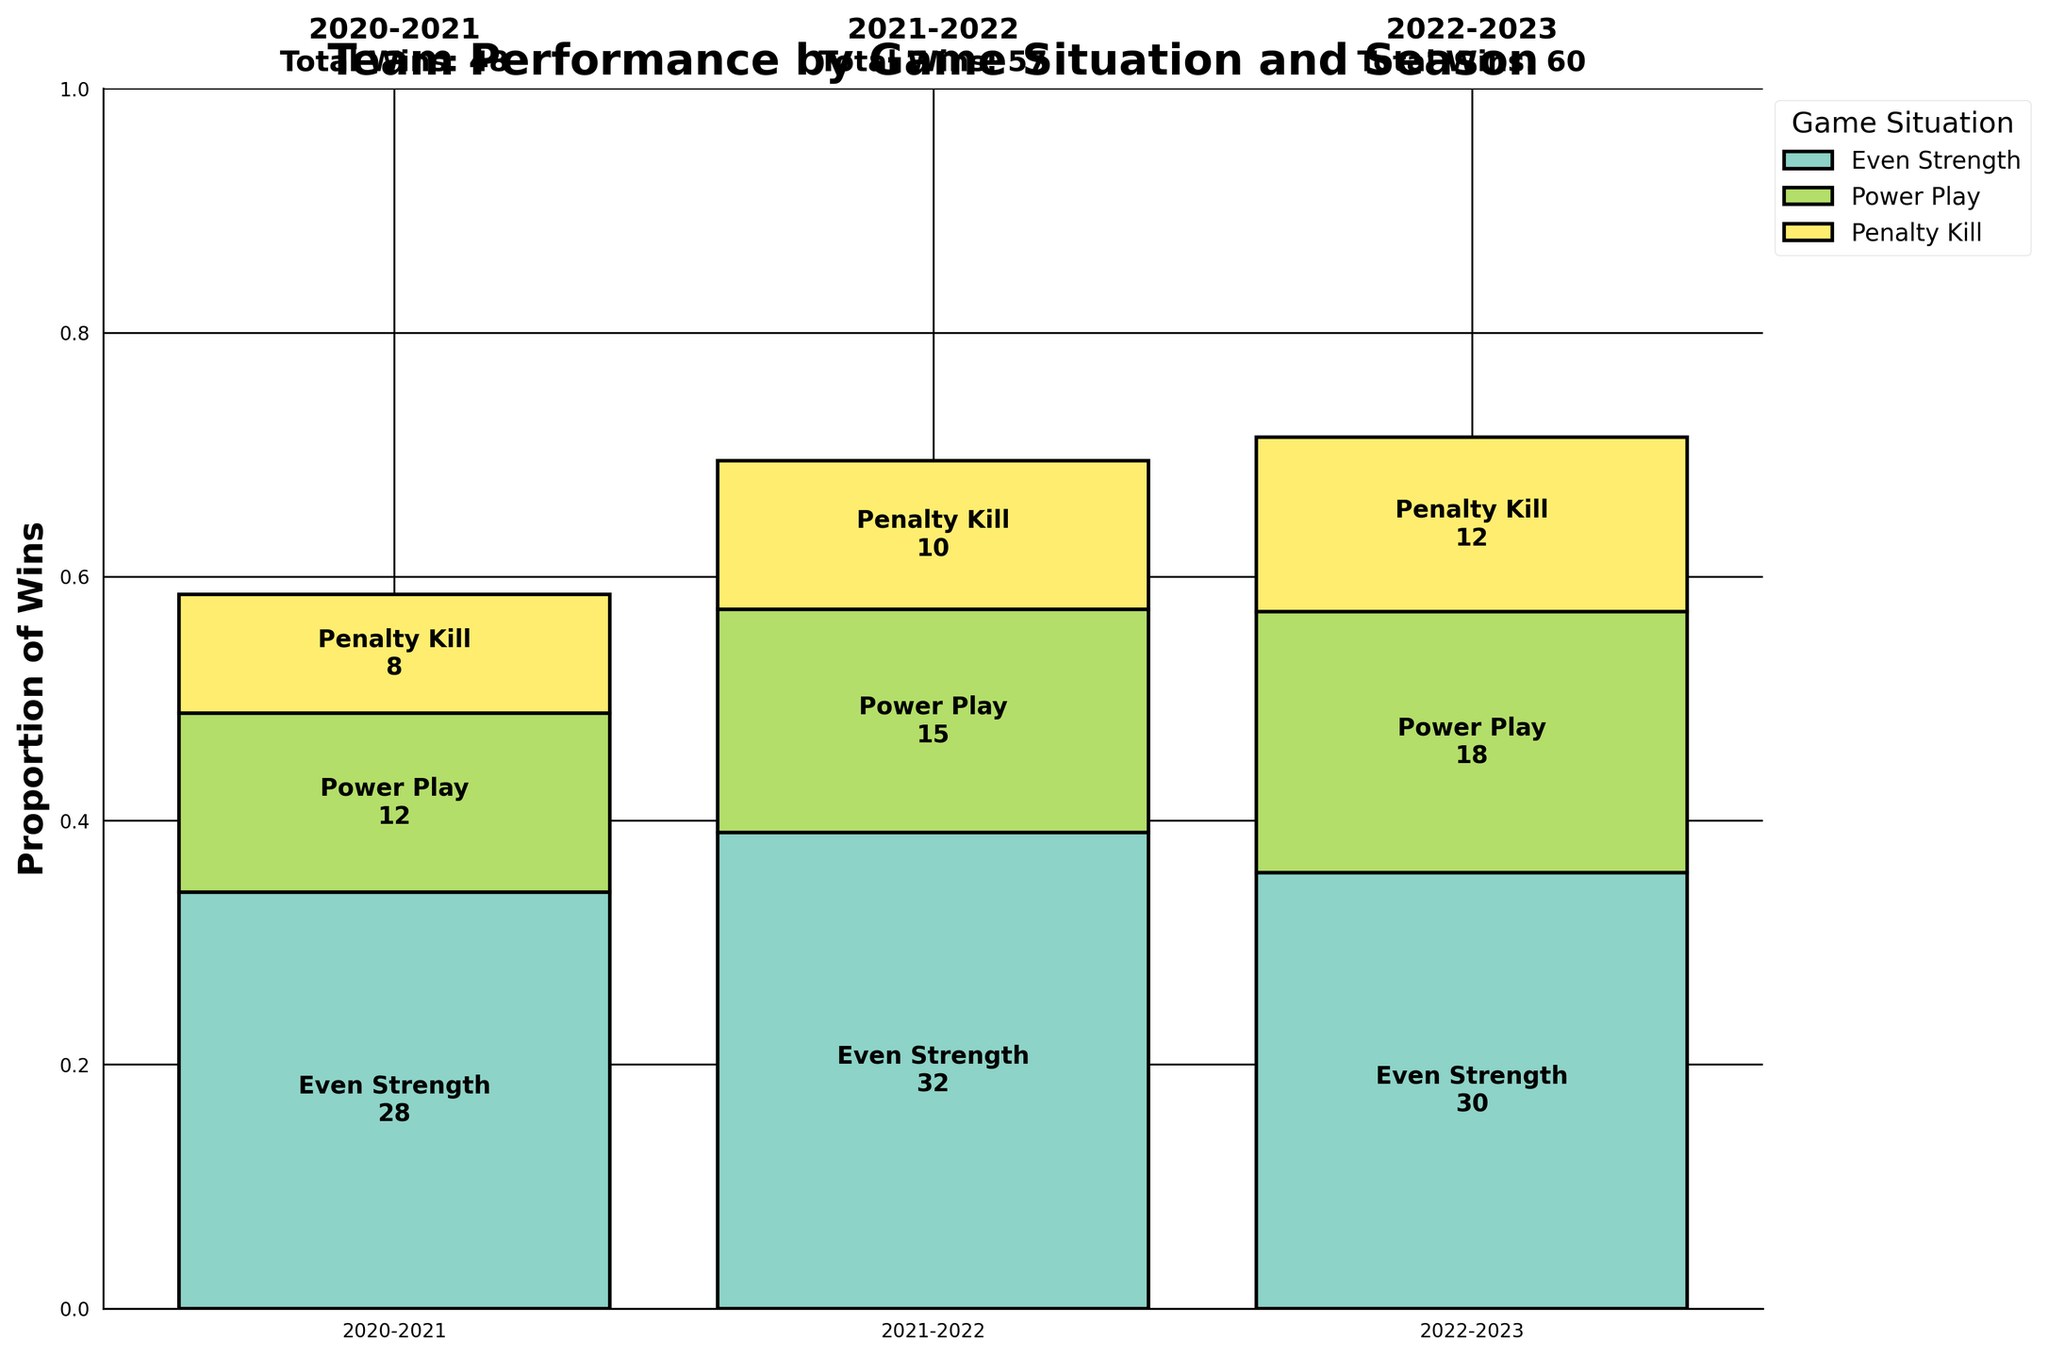What is the title of the plot? The title is located at the top of the figure and gives a summary of what the plot represents.
Answer: Team Performance by Game Situation and Season How many game situations are represented in the plot? The legend on the right side of the plot lists all the game situations with corresponding colors.
Answer: Three Which season had the highest proportion of wins in the Power Play situation? To find this, compare the heights of the bars labeled "Power Play" in each season.
Answer: 2022-2023 What is the total number of wins in the 2021-2022 season? The total number of wins for each season is noted above the bars for each season.
Answer: 57 In which game situation did the team have the fewest wins in the 2020-2021 season? Look at the heights of the bars for each situation in the 2020-2021 season and find the shortest one.
Answer: Penalty Kill What is the proportion of wins in Even Strength for the 2021-2022 season? The proportion of wins is depicted by the height of the "Even Strength" bar relative to 1. That bar height can be visually assessed.
Answer: Approximately 0.37 How does the number of wins in the Penalty Kill situation compare between the 2020-2021 and 2022-2023 seasons? Compare the heights of the bars labeled "Penalty Kill" between the two seasons.
Answer: Higher in 2022-2023 Which season had the most balanced performance across all game situations? Look for the season where the bar heights for the different situations are most similar.
Answer: 2021-2022 In the 2022-2023 season, are there more wins in Power Play or even Strength? Compare the heights of the "Power Play" and "Even Strength" bars in the 2022-2023 season.
Answer: Power Play What is the largest winning margin observed across all seasons and situations? Find the largest single bar height representing wins in any game situation across any season.
Answer: Power Play in 2022-2023 